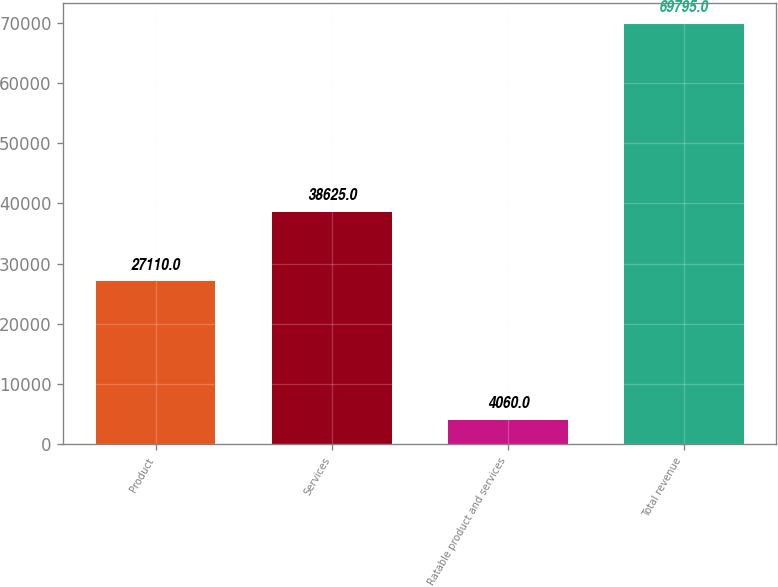Convert chart. <chart><loc_0><loc_0><loc_500><loc_500><bar_chart><fcel>Product<fcel>Services<fcel>Ratable product and services<fcel>Total revenue<nl><fcel>27110<fcel>38625<fcel>4060<fcel>69795<nl></chart> 